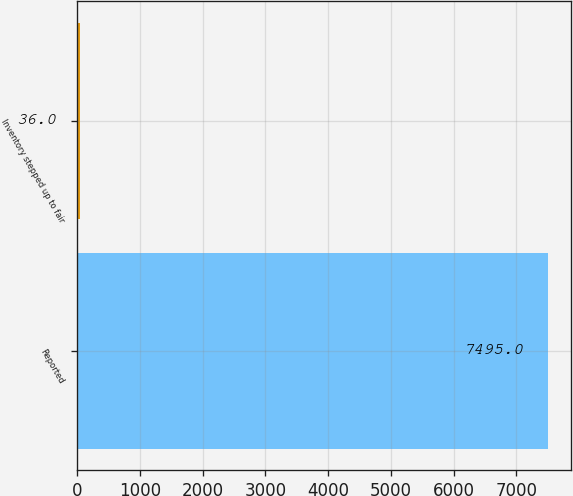Convert chart to OTSL. <chart><loc_0><loc_0><loc_500><loc_500><bar_chart><fcel>Reported<fcel>Inventory stepped up to fair<nl><fcel>7495<fcel>36<nl></chart> 